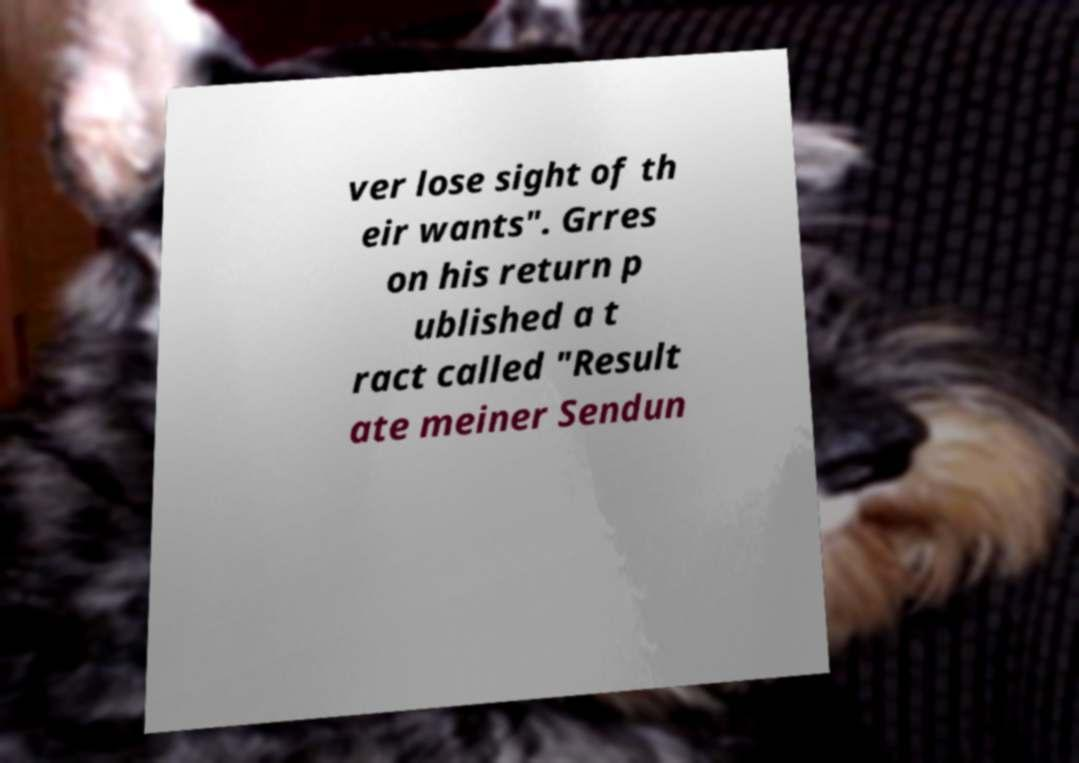Please identify and transcribe the text found in this image. ver lose sight of th eir wants". Grres on his return p ublished a t ract called "Result ate meiner Sendun 